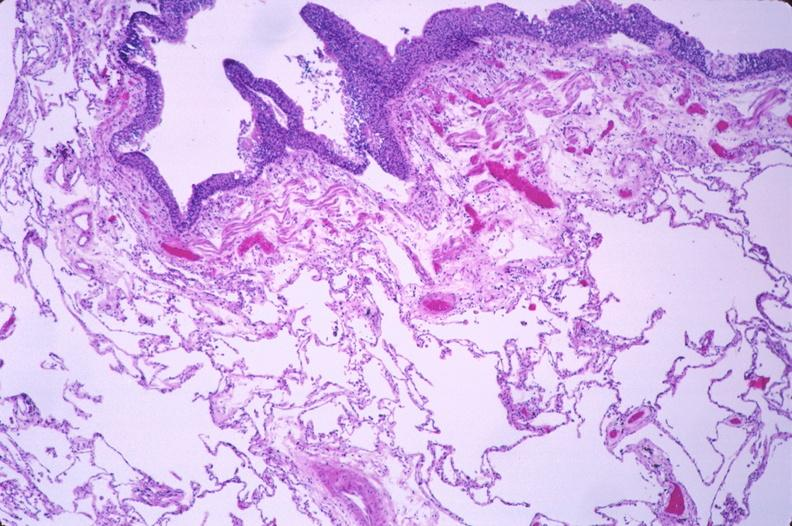where is this?
Answer the question using a single word or phrase. Lung 